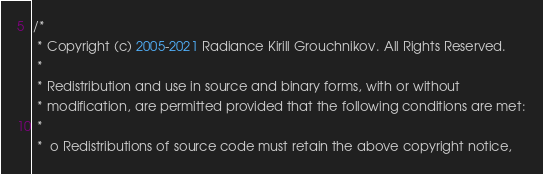Convert code to text. <code><loc_0><loc_0><loc_500><loc_500><_Java_>/*
 * Copyright (c) 2005-2021 Radiance Kirill Grouchnikov. All Rights Reserved.
 *
 * Redistribution and use in source and binary forms, with or without 
 * modification, are permitted provided that the following conditions are met:
 * 
 *  o Redistributions of source code must retain the above copyright notice, </code> 